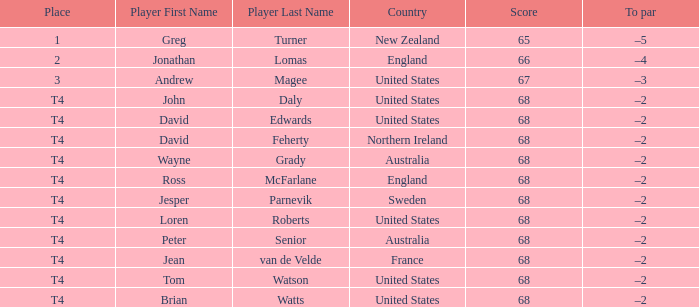Name the Score united states of tom watson in united state? 68.0. 